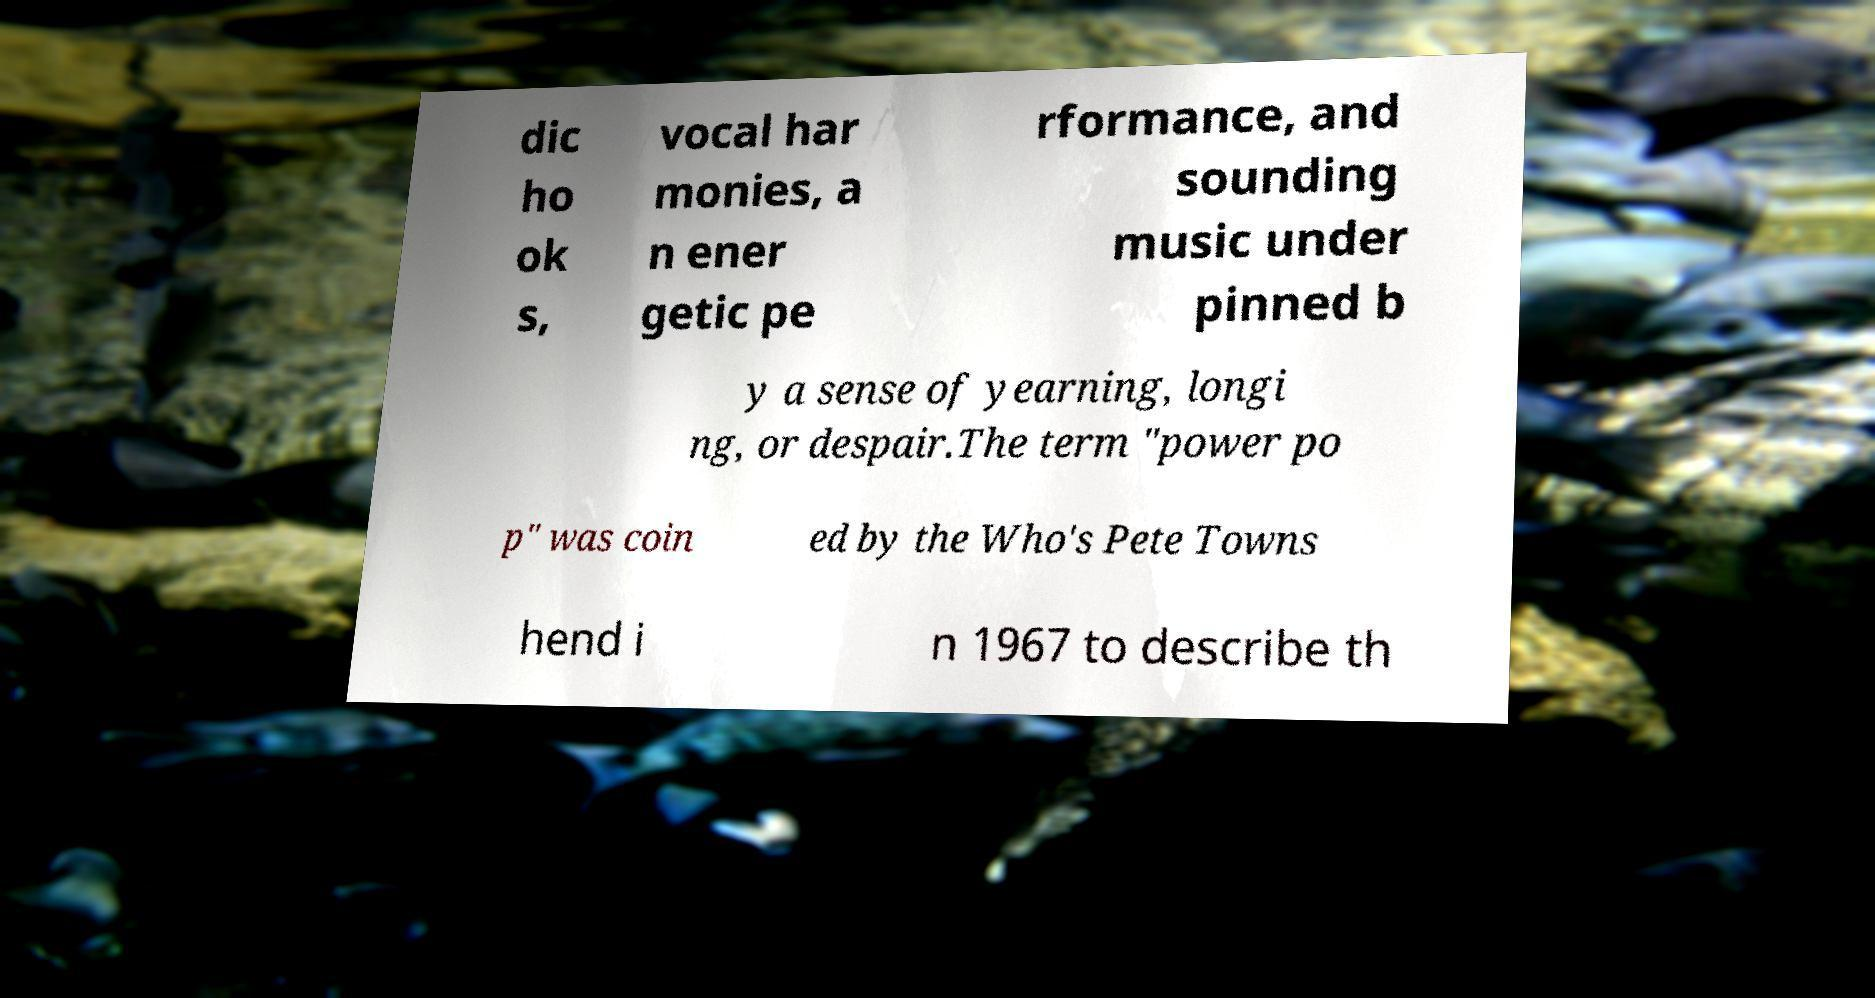What messages or text are displayed in this image? I need them in a readable, typed format. dic ho ok s, vocal har monies, a n ener getic pe rformance, and sounding music under pinned b y a sense of yearning, longi ng, or despair.The term "power po p" was coin ed by the Who's Pete Towns hend i n 1967 to describe th 